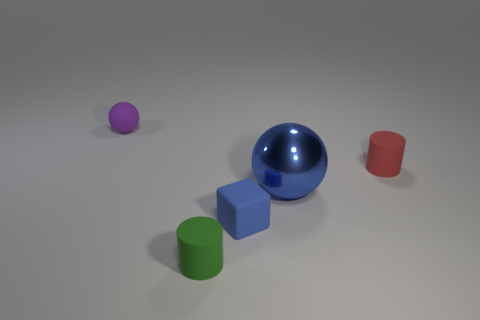The small object that is both behind the blue metal thing and to the right of the purple ball is what color?
Make the answer very short. Red. How many things are things that are behind the tiny green rubber cylinder or big blue metallic spheres?
Make the answer very short. 4. What color is the other object that is the same shape as the shiny thing?
Offer a very short reply. Purple. Does the small red thing have the same shape as the blue object that is left of the blue metal sphere?
Offer a terse response. No. How many things are either cylinders left of the large blue metallic object or matte balls that are left of the large thing?
Provide a succinct answer. 2. Are there fewer tiny rubber cylinders that are left of the tiny matte ball than blue spheres?
Your answer should be very brief. Yes. Is the material of the small purple sphere the same as the small cylinder that is to the left of the red thing?
Ensure brevity in your answer.  Yes. What is the material of the purple ball?
Keep it short and to the point. Rubber. There is a ball that is right of the ball that is behind the cylinder that is on the right side of the small green thing; what is its material?
Make the answer very short. Metal. Does the large ball have the same color as the small matte cylinder behind the green object?
Offer a very short reply. No. 